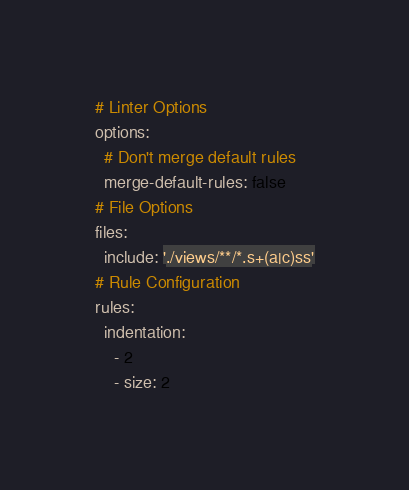Convert code to text. <code><loc_0><loc_0><loc_500><loc_500><_YAML_># Linter Options
options:
  # Don't merge default rules
  merge-default-rules: false
# File Options
files:
  include: './views/**/*.s+(a|c)ss'
# Rule Configuration
rules:
  indentation:
    - 2
    - size: 2</code> 